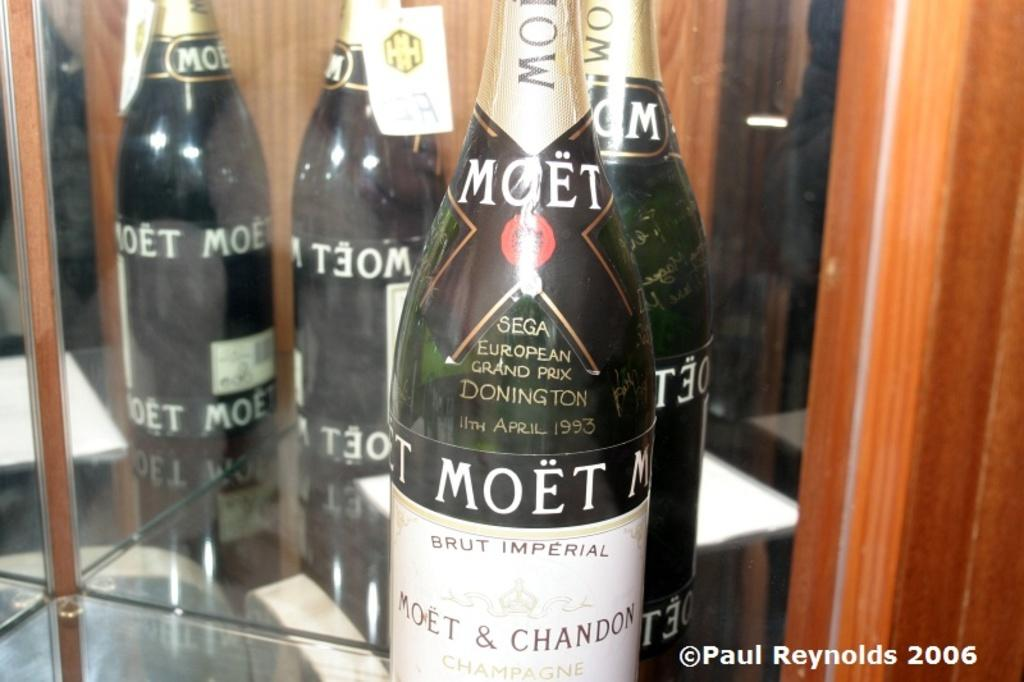<image>
Render a clear and concise summary of the photo. A bottle of Moet from April 1993 on a glass shelf. 